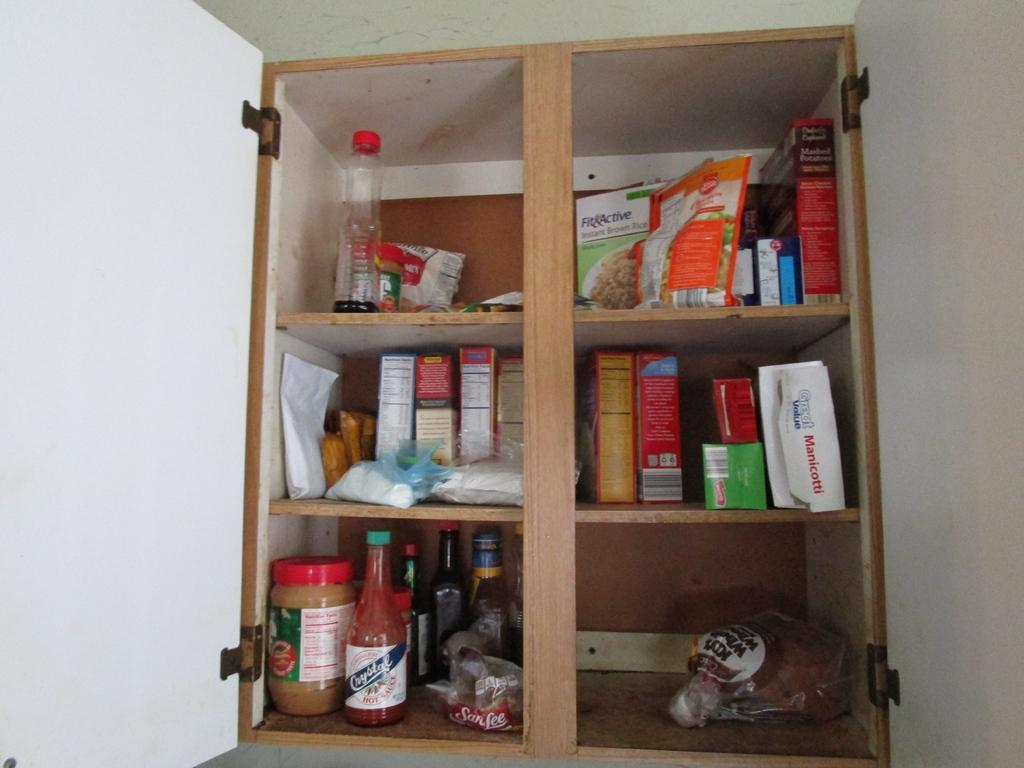Provide a one-sentence caption for the provided image. Among the food items in this open cabinet are Great Value Manicotti and Crystal hot sauce. 